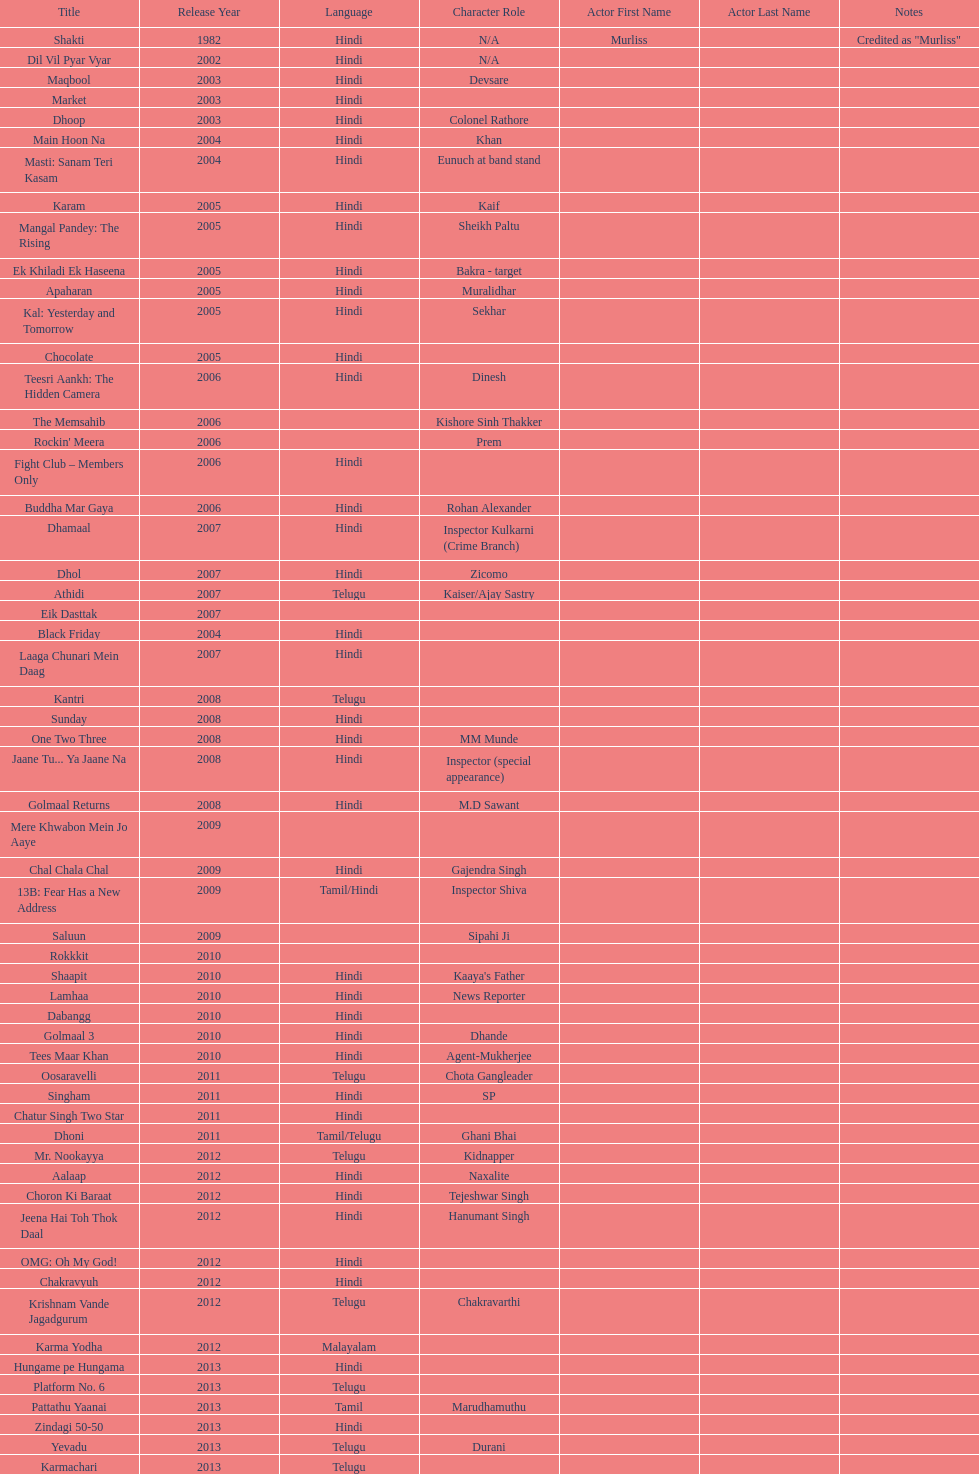What are the number of titles listed in 2005? 6. 